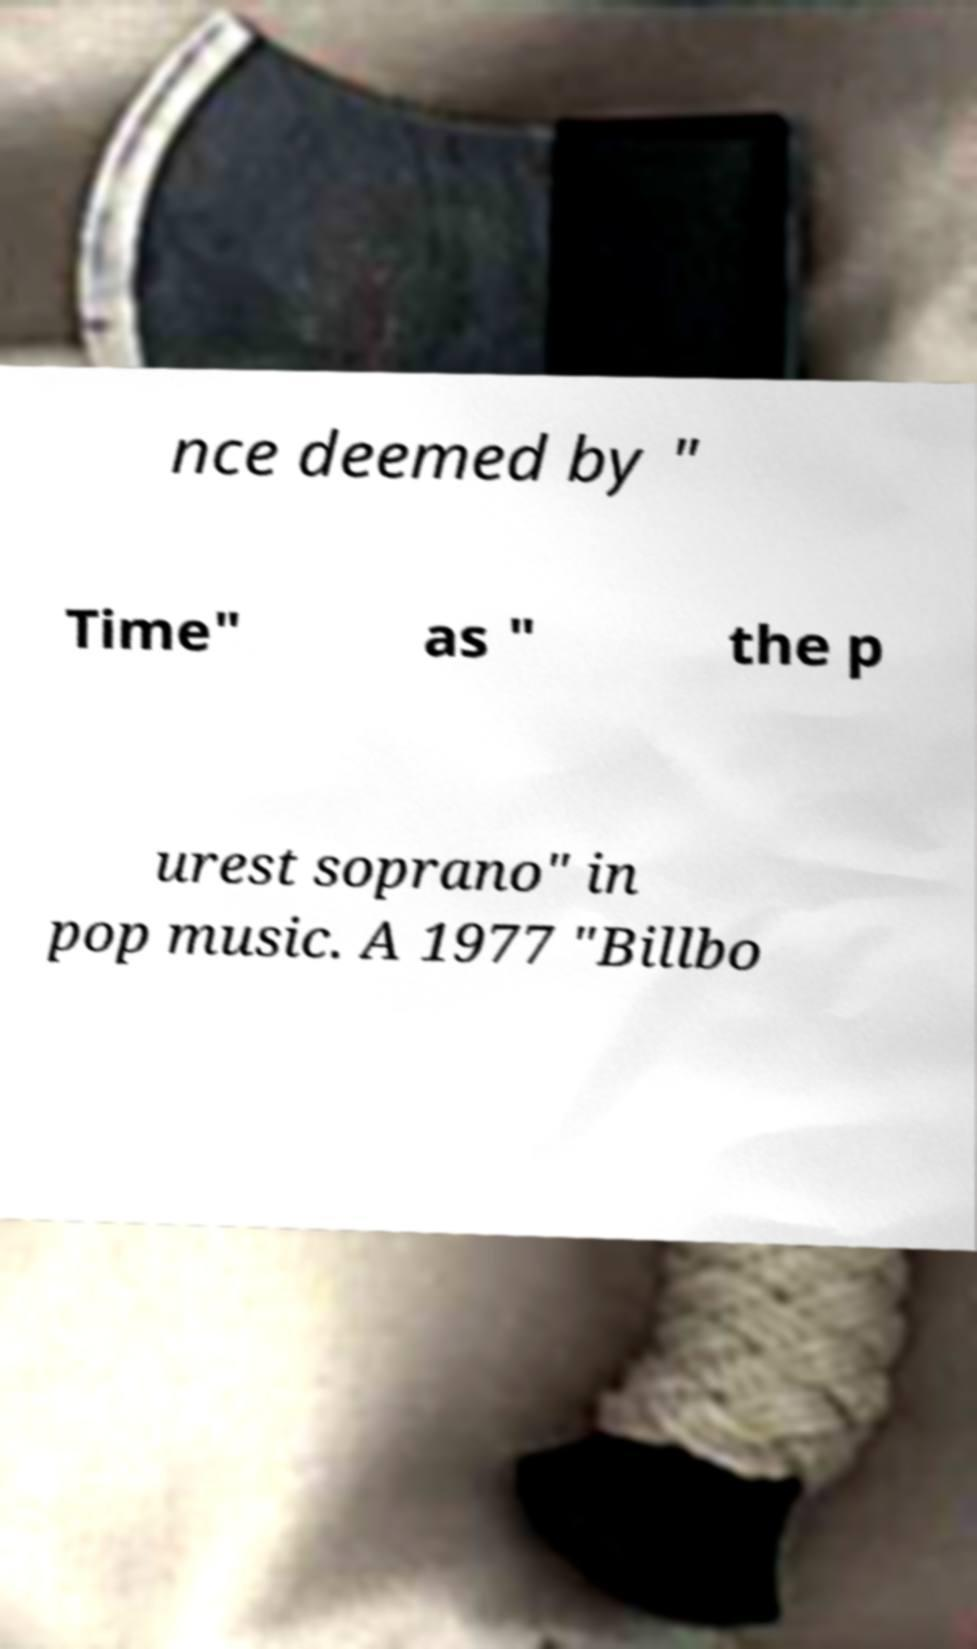For documentation purposes, I need the text within this image transcribed. Could you provide that? nce deemed by " Time" as " the p urest soprano" in pop music. A 1977 "Billbo 